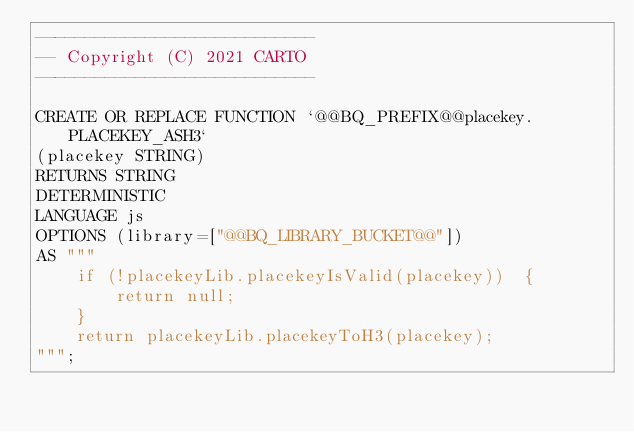Convert code to text. <code><loc_0><loc_0><loc_500><loc_500><_SQL_>----------------------------
-- Copyright (C) 2021 CARTO
----------------------------

CREATE OR REPLACE FUNCTION `@@BQ_PREFIX@@placekey.PLACEKEY_ASH3`
(placekey STRING)
RETURNS STRING
DETERMINISTIC
LANGUAGE js
OPTIONS (library=["@@BQ_LIBRARY_BUCKET@@"])
AS """
    if (!placekeyLib.placekeyIsValid(placekey))  {
        return null;
    }
    return placekeyLib.placekeyToH3(placekey);
""";</code> 